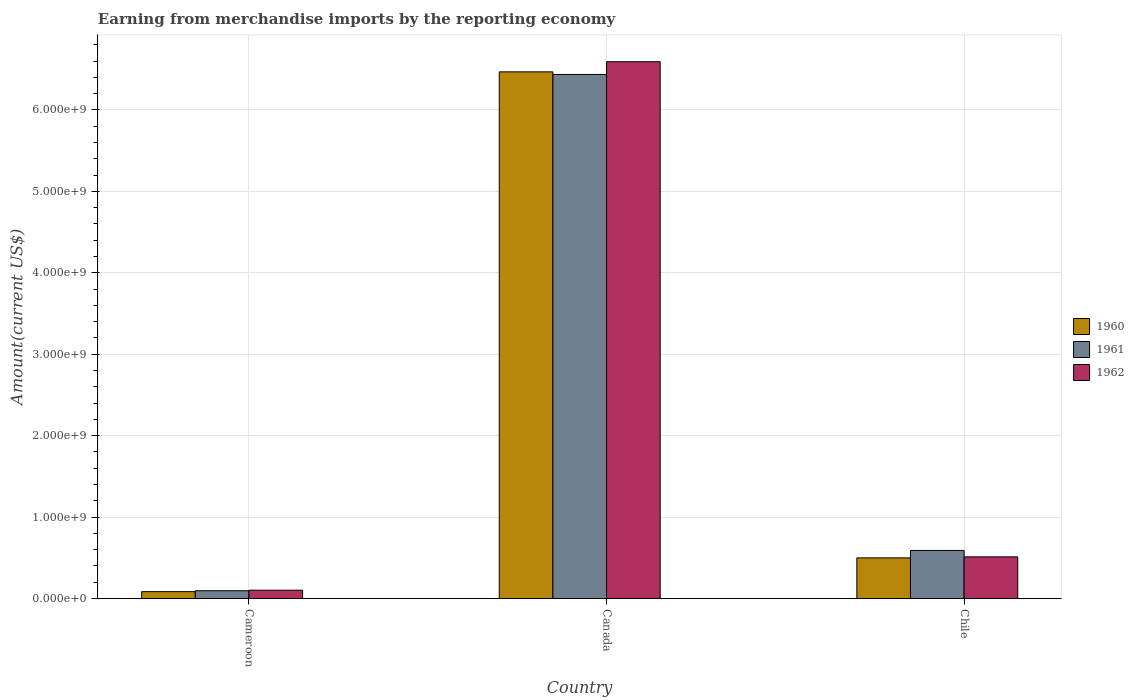How many different coloured bars are there?
Ensure brevity in your answer.  3. How many groups of bars are there?
Give a very brief answer. 3. Are the number of bars on each tick of the X-axis equal?
Your answer should be compact. Yes. What is the label of the 1st group of bars from the left?
Your answer should be very brief. Cameroon. In how many cases, is the number of bars for a given country not equal to the number of legend labels?
Give a very brief answer. 0. What is the amount earned from merchandise imports in 1960 in Cameroon?
Provide a short and direct response. 8.41e+07. Across all countries, what is the maximum amount earned from merchandise imports in 1961?
Provide a succinct answer. 6.44e+09. Across all countries, what is the minimum amount earned from merchandise imports in 1961?
Your answer should be very brief. 9.53e+07. In which country was the amount earned from merchandise imports in 1961 maximum?
Provide a short and direct response. Canada. In which country was the amount earned from merchandise imports in 1961 minimum?
Your answer should be compact. Cameroon. What is the total amount earned from merchandise imports in 1962 in the graph?
Make the answer very short. 7.21e+09. What is the difference between the amount earned from merchandise imports in 1960 in Cameroon and that in Canada?
Keep it short and to the point. -6.38e+09. What is the difference between the amount earned from merchandise imports in 1962 in Cameroon and the amount earned from merchandise imports in 1960 in Canada?
Provide a short and direct response. -6.37e+09. What is the average amount earned from merchandise imports in 1962 per country?
Your answer should be very brief. 2.40e+09. What is the difference between the amount earned from merchandise imports of/in 1962 and amount earned from merchandise imports of/in 1961 in Cameroon?
Your response must be concise. 6.50e+06. What is the ratio of the amount earned from merchandise imports in 1960 in Cameroon to that in Canada?
Give a very brief answer. 0.01. Is the difference between the amount earned from merchandise imports in 1962 in Cameroon and Canada greater than the difference between the amount earned from merchandise imports in 1961 in Cameroon and Canada?
Keep it short and to the point. No. What is the difference between the highest and the second highest amount earned from merchandise imports in 1961?
Make the answer very short. 6.34e+09. What is the difference between the highest and the lowest amount earned from merchandise imports in 1962?
Your answer should be very brief. 6.49e+09. In how many countries, is the amount earned from merchandise imports in 1961 greater than the average amount earned from merchandise imports in 1961 taken over all countries?
Keep it short and to the point. 1. Is it the case that in every country, the sum of the amount earned from merchandise imports in 1960 and amount earned from merchandise imports in 1962 is greater than the amount earned from merchandise imports in 1961?
Keep it short and to the point. Yes. Are all the bars in the graph horizontal?
Provide a succinct answer. No. How many countries are there in the graph?
Make the answer very short. 3. Does the graph contain any zero values?
Ensure brevity in your answer.  No. Does the graph contain grids?
Keep it short and to the point. Yes. Where does the legend appear in the graph?
Make the answer very short. Center right. How many legend labels are there?
Your response must be concise. 3. How are the legend labels stacked?
Your response must be concise. Vertical. What is the title of the graph?
Make the answer very short. Earning from merchandise imports by the reporting economy. What is the label or title of the X-axis?
Provide a short and direct response. Country. What is the label or title of the Y-axis?
Keep it short and to the point. Amount(current US$). What is the Amount(current US$) in 1960 in Cameroon?
Provide a short and direct response. 8.41e+07. What is the Amount(current US$) of 1961 in Cameroon?
Provide a succinct answer. 9.53e+07. What is the Amount(current US$) in 1962 in Cameroon?
Give a very brief answer. 1.02e+08. What is the Amount(current US$) in 1960 in Canada?
Your answer should be very brief. 6.47e+09. What is the Amount(current US$) of 1961 in Canada?
Your answer should be compact. 6.44e+09. What is the Amount(current US$) in 1962 in Canada?
Your response must be concise. 6.59e+09. What is the Amount(current US$) of 1960 in Chile?
Your answer should be compact. 4.99e+08. What is the Amount(current US$) of 1961 in Chile?
Keep it short and to the point. 5.90e+08. What is the Amount(current US$) of 1962 in Chile?
Keep it short and to the point. 5.11e+08. Across all countries, what is the maximum Amount(current US$) in 1960?
Provide a succinct answer. 6.47e+09. Across all countries, what is the maximum Amount(current US$) of 1961?
Keep it short and to the point. 6.44e+09. Across all countries, what is the maximum Amount(current US$) of 1962?
Provide a succinct answer. 6.59e+09. Across all countries, what is the minimum Amount(current US$) of 1960?
Offer a very short reply. 8.41e+07. Across all countries, what is the minimum Amount(current US$) in 1961?
Keep it short and to the point. 9.53e+07. Across all countries, what is the minimum Amount(current US$) of 1962?
Your response must be concise. 1.02e+08. What is the total Amount(current US$) in 1960 in the graph?
Your answer should be compact. 7.05e+09. What is the total Amount(current US$) in 1961 in the graph?
Offer a very short reply. 7.12e+09. What is the total Amount(current US$) in 1962 in the graph?
Keep it short and to the point. 7.21e+09. What is the difference between the Amount(current US$) of 1960 in Cameroon and that in Canada?
Ensure brevity in your answer.  -6.38e+09. What is the difference between the Amount(current US$) of 1961 in Cameroon and that in Canada?
Provide a succinct answer. -6.34e+09. What is the difference between the Amount(current US$) in 1962 in Cameroon and that in Canada?
Keep it short and to the point. -6.49e+09. What is the difference between the Amount(current US$) in 1960 in Cameroon and that in Chile?
Your answer should be very brief. -4.15e+08. What is the difference between the Amount(current US$) in 1961 in Cameroon and that in Chile?
Provide a succinct answer. -4.95e+08. What is the difference between the Amount(current US$) of 1962 in Cameroon and that in Chile?
Your answer should be very brief. -4.10e+08. What is the difference between the Amount(current US$) in 1960 in Canada and that in Chile?
Make the answer very short. 5.97e+09. What is the difference between the Amount(current US$) of 1961 in Canada and that in Chile?
Provide a short and direct response. 5.85e+09. What is the difference between the Amount(current US$) in 1962 in Canada and that in Chile?
Give a very brief answer. 6.08e+09. What is the difference between the Amount(current US$) in 1960 in Cameroon and the Amount(current US$) in 1961 in Canada?
Provide a short and direct response. -6.35e+09. What is the difference between the Amount(current US$) in 1960 in Cameroon and the Amount(current US$) in 1962 in Canada?
Keep it short and to the point. -6.51e+09. What is the difference between the Amount(current US$) of 1961 in Cameroon and the Amount(current US$) of 1962 in Canada?
Provide a succinct answer. -6.50e+09. What is the difference between the Amount(current US$) in 1960 in Cameroon and the Amount(current US$) in 1961 in Chile?
Keep it short and to the point. -5.06e+08. What is the difference between the Amount(current US$) in 1960 in Cameroon and the Amount(current US$) in 1962 in Chile?
Your answer should be compact. -4.27e+08. What is the difference between the Amount(current US$) of 1961 in Cameroon and the Amount(current US$) of 1962 in Chile?
Your response must be concise. -4.16e+08. What is the difference between the Amount(current US$) in 1960 in Canada and the Amount(current US$) in 1961 in Chile?
Ensure brevity in your answer.  5.88e+09. What is the difference between the Amount(current US$) of 1960 in Canada and the Amount(current US$) of 1962 in Chile?
Your answer should be very brief. 5.96e+09. What is the difference between the Amount(current US$) of 1961 in Canada and the Amount(current US$) of 1962 in Chile?
Your answer should be compact. 5.92e+09. What is the average Amount(current US$) in 1960 per country?
Ensure brevity in your answer.  2.35e+09. What is the average Amount(current US$) in 1961 per country?
Your answer should be very brief. 2.37e+09. What is the average Amount(current US$) of 1962 per country?
Provide a succinct answer. 2.40e+09. What is the difference between the Amount(current US$) in 1960 and Amount(current US$) in 1961 in Cameroon?
Offer a terse response. -1.12e+07. What is the difference between the Amount(current US$) in 1960 and Amount(current US$) in 1962 in Cameroon?
Make the answer very short. -1.77e+07. What is the difference between the Amount(current US$) in 1961 and Amount(current US$) in 1962 in Cameroon?
Provide a short and direct response. -6.50e+06. What is the difference between the Amount(current US$) in 1960 and Amount(current US$) in 1961 in Canada?
Offer a terse response. 3.20e+07. What is the difference between the Amount(current US$) of 1960 and Amount(current US$) of 1962 in Canada?
Offer a terse response. -1.24e+08. What is the difference between the Amount(current US$) of 1961 and Amount(current US$) of 1962 in Canada?
Keep it short and to the point. -1.56e+08. What is the difference between the Amount(current US$) in 1960 and Amount(current US$) in 1961 in Chile?
Keep it short and to the point. -9.14e+07. What is the difference between the Amount(current US$) in 1960 and Amount(current US$) in 1962 in Chile?
Ensure brevity in your answer.  -1.25e+07. What is the difference between the Amount(current US$) in 1961 and Amount(current US$) in 1962 in Chile?
Your response must be concise. 7.89e+07. What is the ratio of the Amount(current US$) of 1960 in Cameroon to that in Canada?
Keep it short and to the point. 0.01. What is the ratio of the Amount(current US$) of 1961 in Cameroon to that in Canada?
Ensure brevity in your answer.  0.01. What is the ratio of the Amount(current US$) of 1962 in Cameroon to that in Canada?
Ensure brevity in your answer.  0.02. What is the ratio of the Amount(current US$) in 1960 in Cameroon to that in Chile?
Provide a succinct answer. 0.17. What is the ratio of the Amount(current US$) in 1961 in Cameroon to that in Chile?
Offer a terse response. 0.16. What is the ratio of the Amount(current US$) of 1962 in Cameroon to that in Chile?
Your answer should be compact. 0.2. What is the ratio of the Amount(current US$) of 1960 in Canada to that in Chile?
Offer a very short reply. 12.97. What is the ratio of the Amount(current US$) of 1961 in Canada to that in Chile?
Offer a very short reply. 10.9. What is the ratio of the Amount(current US$) of 1962 in Canada to that in Chile?
Make the answer very short. 12.89. What is the difference between the highest and the second highest Amount(current US$) of 1960?
Your answer should be very brief. 5.97e+09. What is the difference between the highest and the second highest Amount(current US$) in 1961?
Ensure brevity in your answer.  5.85e+09. What is the difference between the highest and the second highest Amount(current US$) of 1962?
Ensure brevity in your answer.  6.08e+09. What is the difference between the highest and the lowest Amount(current US$) of 1960?
Make the answer very short. 6.38e+09. What is the difference between the highest and the lowest Amount(current US$) of 1961?
Keep it short and to the point. 6.34e+09. What is the difference between the highest and the lowest Amount(current US$) in 1962?
Your answer should be compact. 6.49e+09. 